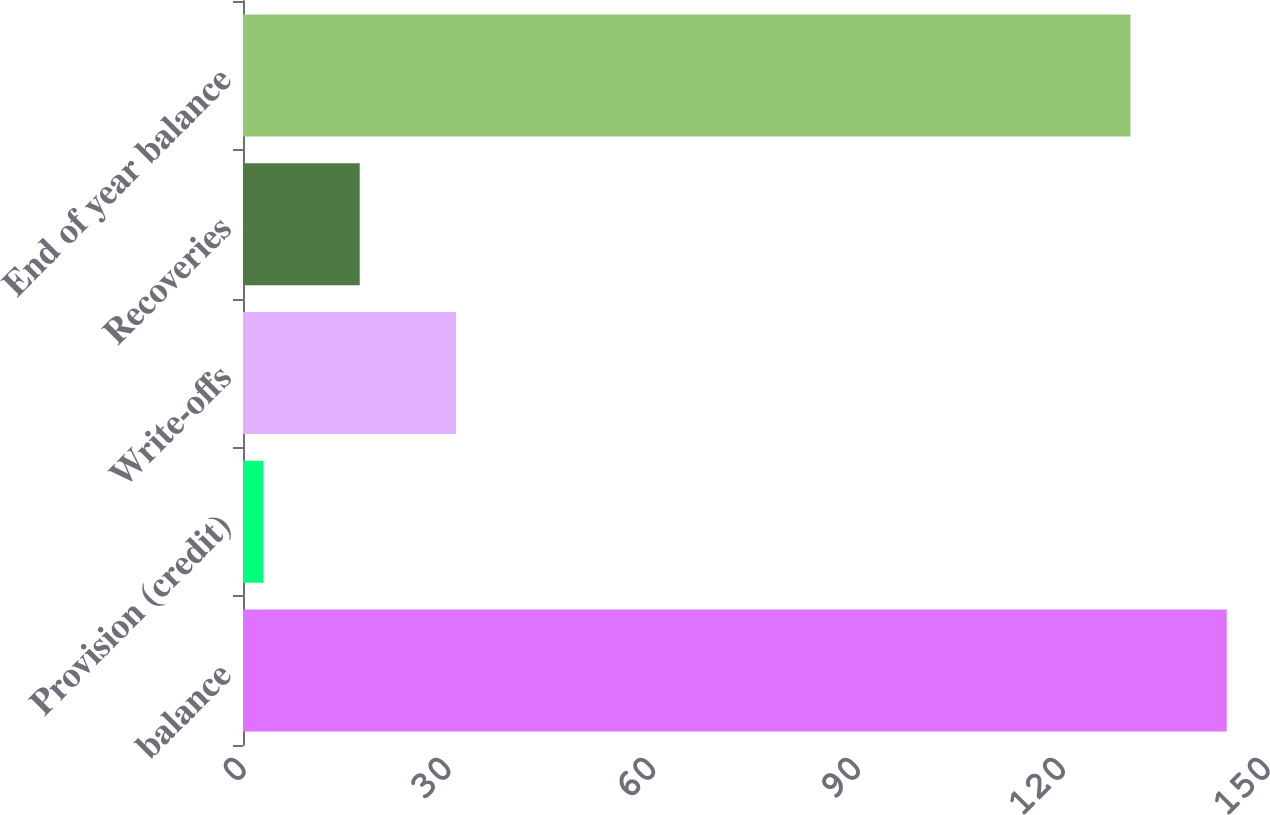Convert chart to OTSL. <chart><loc_0><loc_0><loc_500><loc_500><bar_chart><fcel>balance<fcel>Provision (credit)<fcel>Write-offs<fcel>Recoveries<fcel>End of year balance<nl><fcel>144.1<fcel>3<fcel>31.2<fcel>17.1<fcel>130<nl></chart> 